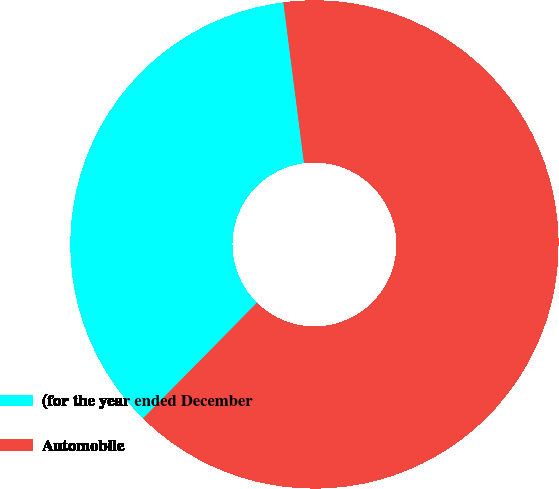Convert chart to OTSL. <chart><loc_0><loc_0><loc_500><loc_500><pie_chart><fcel>(for the year ended December<fcel>Automobile<nl><fcel>35.59%<fcel>64.41%<nl></chart> 